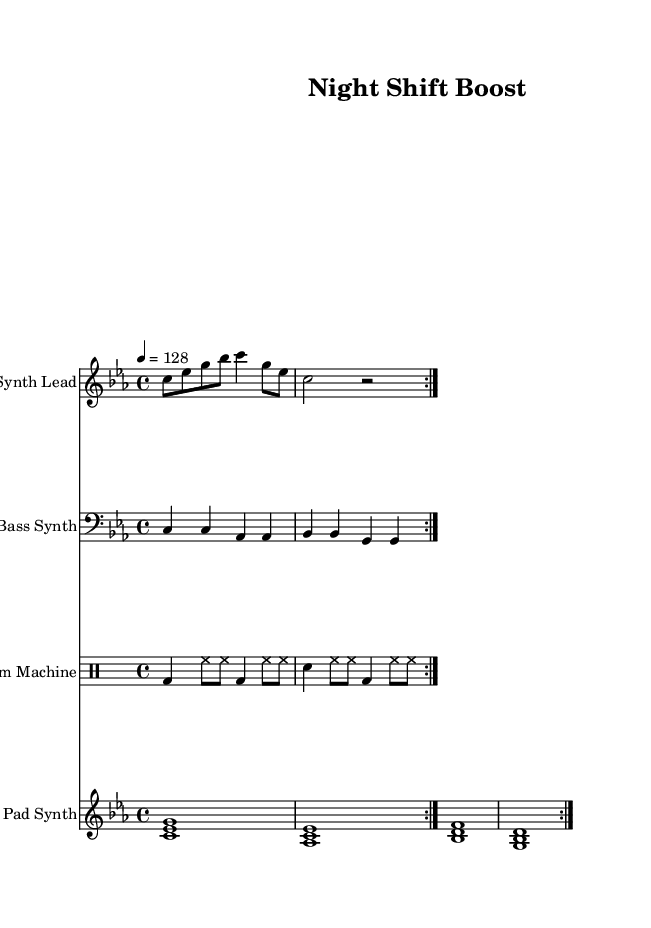What is the key signature of this music? The key signature is indicated at the beginning of the staff, showing three flats which corresponds to C minor.
Answer: C minor What is the time signature of this music? The time signature appears at the beginning of the staff, represented by "4/4," which indicates that there are four beats in a measure and the quarter note gets one beat.
Answer: 4/4 What is the tempo of this music? The tempo marking appears above the music, stating "4 = 128," which means the piece should be played at a speed of 128 beats per minute.
Answer: 128 How many measures are repeated in the synth lead section? The synth lead part contains a repeat sign suggesting that the section should be played two times, as indicated by "volta 2."
Answer: 2 In this piece, what type of synth is used for the bass line? The bass line is labeled "Bass Synth" on the staff, indicating the specific type of synthesizer sound used in this section.
Answer: Bass Synth What rhythmic element is dominant in the drum machine section? The drum machine consists primarily of a bass drum and hi-hat pattern, with the bass drum on the downbeat and hi-hats providing a steady rhythm, emphasizing the dance style.
Answer: Bass drum and hi-hat What is the texture of the pad synth section? The pad synth is composed of rich, sustained chords as indicated by the notation of intervals, creating a layered effect typical of electronic dance music.
Answer: Sustained chords 